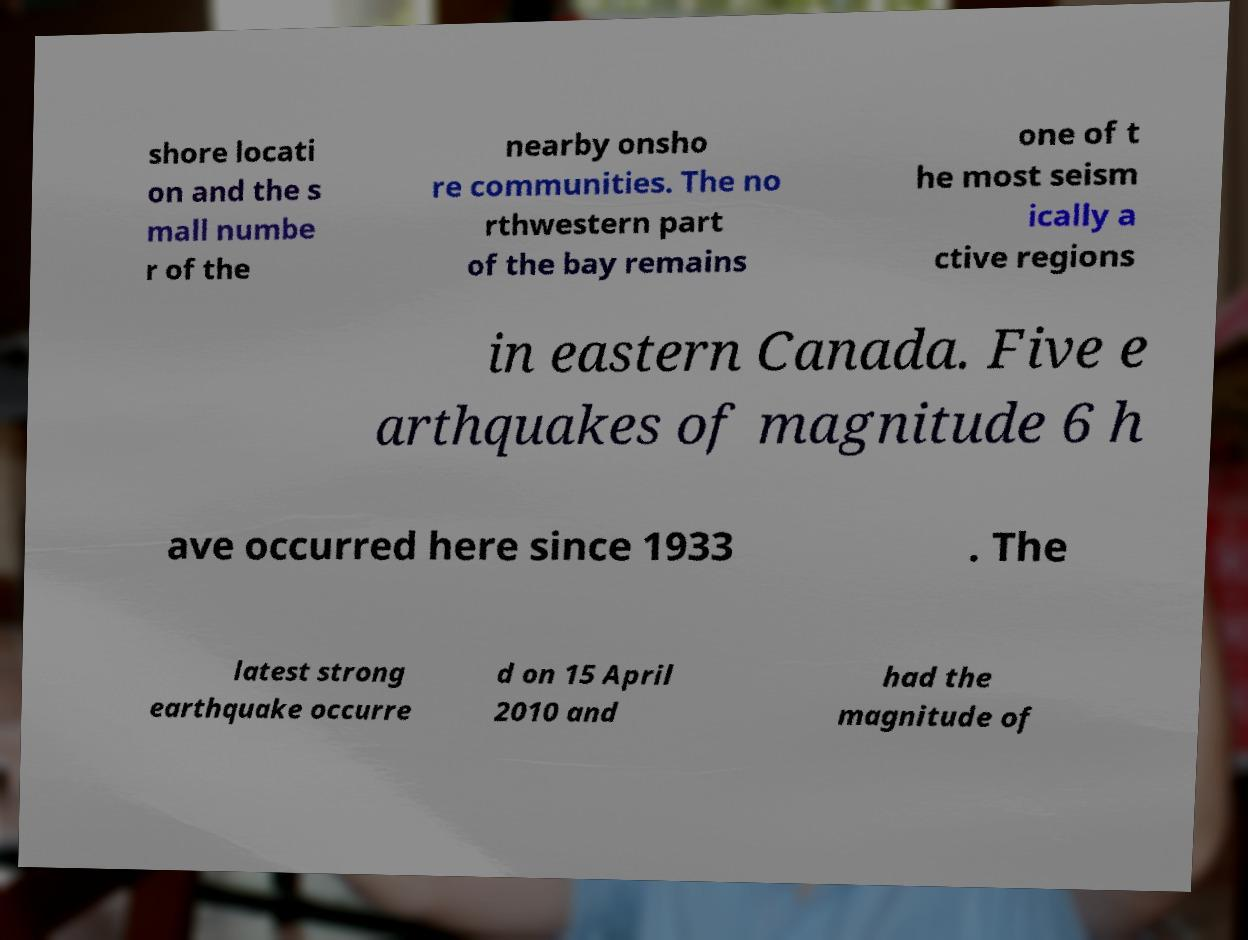Please identify and transcribe the text found in this image. shore locati on and the s mall numbe r of the nearby onsho re communities. The no rthwestern part of the bay remains one of t he most seism ically a ctive regions in eastern Canada. Five e arthquakes of magnitude 6 h ave occurred here since 1933 . The latest strong earthquake occurre d on 15 April 2010 and had the magnitude of 